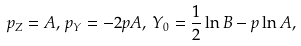Convert formula to latex. <formula><loc_0><loc_0><loc_500><loc_500>p _ { Z } = A , \, p _ { Y } = - 2 p A , \, Y _ { 0 } = \frac { 1 } { 2 } \ln { B } - p \ln { A } ,</formula> 